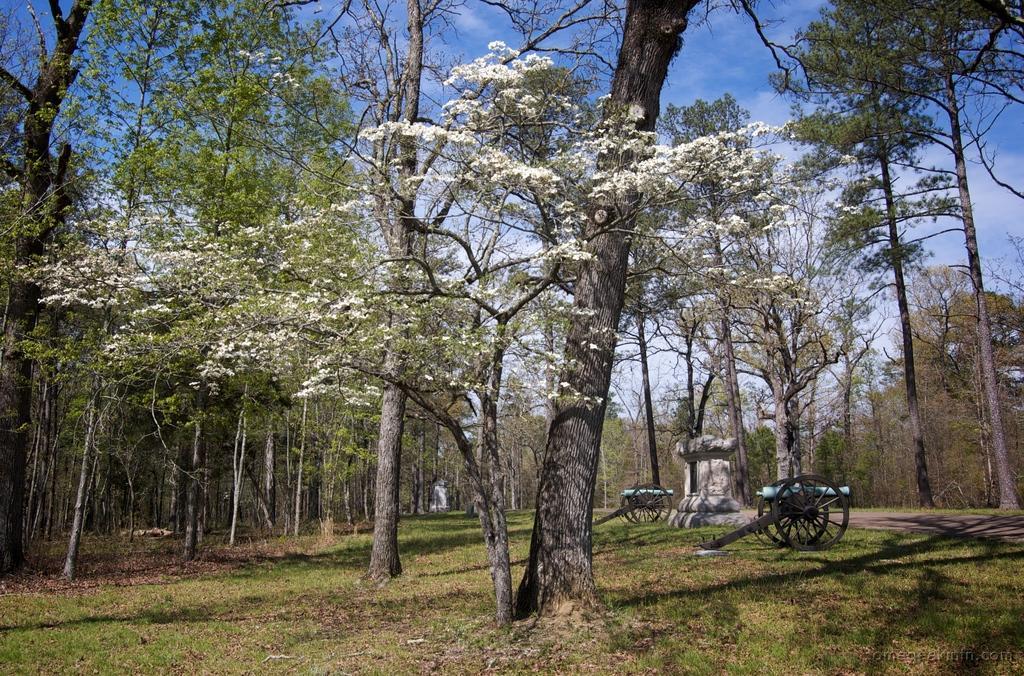Can you describe this image briefly? In this image we can see many trees. We can also see the carts, grass, path and also a concrete structure. Sky is also visible with the clouds. 